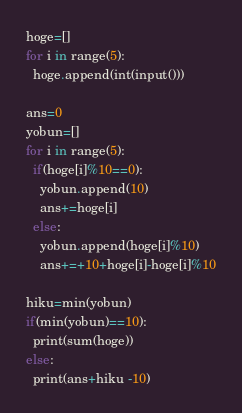Convert code to text. <code><loc_0><loc_0><loc_500><loc_500><_Python_>hoge=[]
for i in range(5):
  hoge.append(int(input()))
  
ans=0
yobun=[]
for i in range(5):
  if(hoge[i]%10==0):
    yobun.append(10)
    ans+=hoge[i]
  else:
    yobun.append(hoge[i]%10)
    ans+=+10+hoge[i]-hoge[i]%10
    
hiku=min(yobun)
if(min(yobun)==10):
  print(sum(hoge))
else:
  print(ans+hiku -10)</code> 